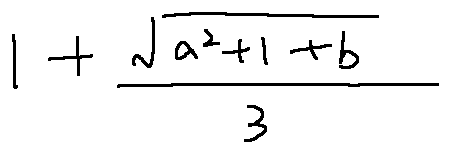<formula> <loc_0><loc_0><loc_500><loc_500>1 + \frac { \sqrt { a ^ { 2 } + 1 + b } } { 3 }</formula> 